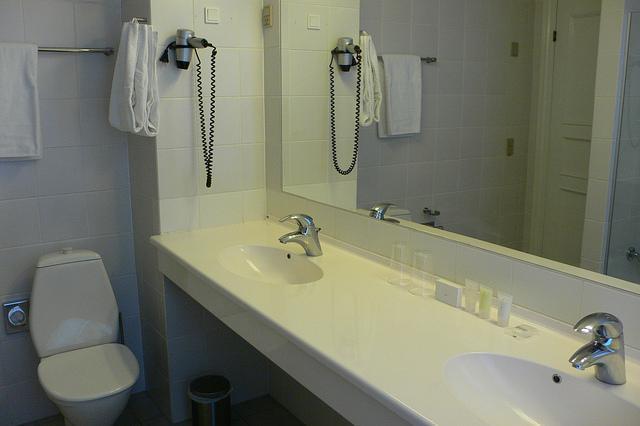How many sinks are visible?
Give a very brief answer. 2. How many sinks are in the picture?
Give a very brief answer. 2. How many people are wearing hat?
Give a very brief answer. 0. 